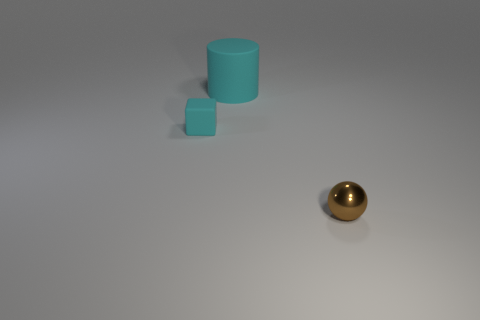Add 1 cyan objects. How many objects exist? 4 Subtract all cylinders. How many objects are left? 2 Subtract all yellow spheres. Subtract all small rubber cubes. How many objects are left? 2 Add 2 rubber cubes. How many rubber cubes are left? 3 Add 1 tiny blue spheres. How many tiny blue spheres exist? 1 Subtract 1 cyan cylinders. How many objects are left? 2 